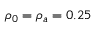<formula> <loc_0><loc_0><loc_500><loc_500>\rho _ { 0 } = \rho _ { a } = 0 . 2 5</formula> 